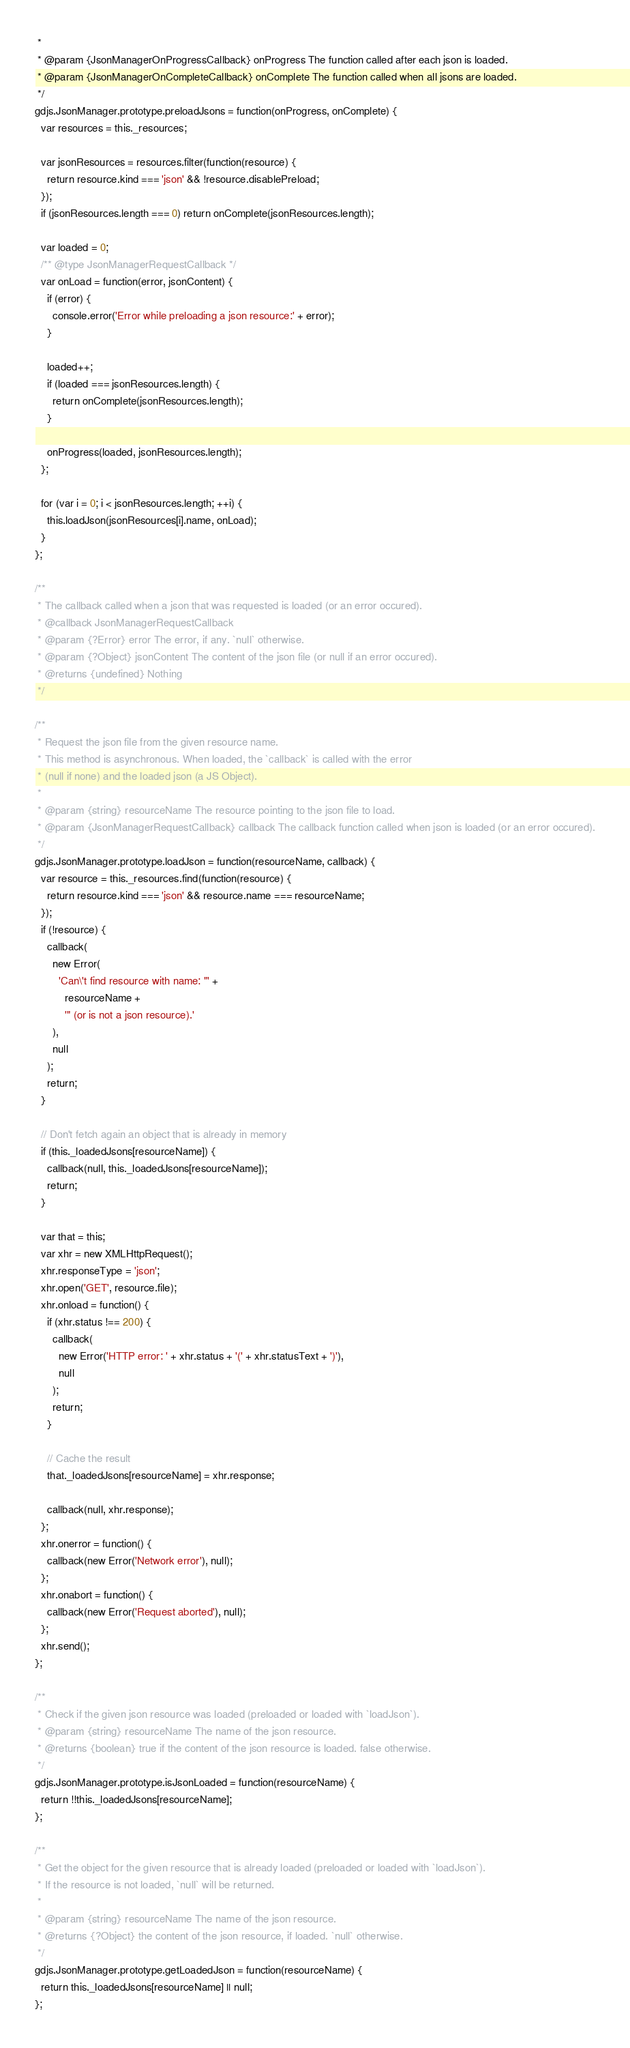<code> <loc_0><loc_0><loc_500><loc_500><_JavaScript_> *
 * @param {JsonManagerOnProgressCallback} onProgress The function called after each json is loaded.
 * @param {JsonManagerOnCompleteCallback} onComplete The function called when all jsons are loaded.
 */
gdjs.JsonManager.prototype.preloadJsons = function(onProgress, onComplete) {
  var resources = this._resources;

  var jsonResources = resources.filter(function(resource) {
    return resource.kind === 'json' && !resource.disablePreload;
  });
  if (jsonResources.length === 0) return onComplete(jsonResources.length);

  var loaded = 0;
  /** @type JsonManagerRequestCallback */
  var onLoad = function(error, jsonContent) {
    if (error) {
      console.error('Error while preloading a json resource:' + error);
    }

    loaded++;
    if (loaded === jsonResources.length) {
      return onComplete(jsonResources.length);
    }

    onProgress(loaded, jsonResources.length);
  };

  for (var i = 0; i < jsonResources.length; ++i) {
    this.loadJson(jsonResources[i].name, onLoad);
  }
};

/**
 * The callback called when a json that was requested is loaded (or an error occured).
 * @callback JsonManagerRequestCallback
 * @param {?Error} error The error, if any. `null` otherwise.
 * @param {?Object} jsonContent The content of the json file (or null if an error occured).
 * @returns {undefined} Nothing
 */

/**
 * Request the json file from the given resource name.
 * This method is asynchronous. When loaded, the `callback` is called with the error
 * (null if none) and the loaded json (a JS Object).
 *
 * @param {string} resourceName The resource pointing to the json file to load.
 * @param {JsonManagerRequestCallback} callback The callback function called when json is loaded (or an error occured).
 */
gdjs.JsonManager.prototype.loadJson = function(resourceName, callback) {
  var resource = this._resources.find(function(resource) {
    return resource.kind === 'json' && resource.name === resourceName;
  });
  if (!resource) {
    callback(
      new Error(
        'Can\'t find resource with name: "' +
          resourceName +
          '" (or is not a json resource).'
      ),
      null
    );
    return;
  }

  // Don't fetch again an object that is already in memory
  if (this._loadedJsons[resourceName]) {
    callback(null, this._loadedJsons[resourceName]);
    return;
  }

  var that = this;
  var xhr = new XMLHttpRequest();
  xhr.responseType = 'json';
  xhr.open('GET', resource.file);
  xhr.onload = function() {
    if (xhr.status !== 200) {
      callback(
        new Error('HTTP error: ' + xhr.status + '(' + xhr.statusText + ')'),
        null
      );
      return;
    }

    // Cache the result
    that._loadedJsons[resourceName] = xhr.response;

    callback(null, xhr.response);
  };
  xhr.onerror = function() {
    callback(new Error('Network error'), null);
  };
  xhr.onabort = function() {
    callback(new Error('Request aborted'), null);
  };
  xhr.send();
};

/**
 * Check if the given json resource was loaded (preloaded or loaded with `loadJson`).
 * @param {string} resourceName The name of the json resource.
 * @returns {boolean} true if the content of the json resource is loaded. false otherwise.
 */
gdjs.JsonManager.prototype.isJsonLoaded = function(resourceName) {
  return !!this._loadedJsons[resourceName];
};

/**
 * Get the object for the given resource that is already loaded (preloaded or loaded with `loadJson`).
 * If the resource is not loaded, `null` will be returned.
 *
 * @param {string} resourceName The name of the json resource.
 * @returns {?Object} the content of the json resource, if loaded. `null` otherwise.
 */
gdjs.JsonManager.prototype.getLoadedJson = function(resourceName) {
  return this._loadedJsons[resourceName] || null;
};
</code> 